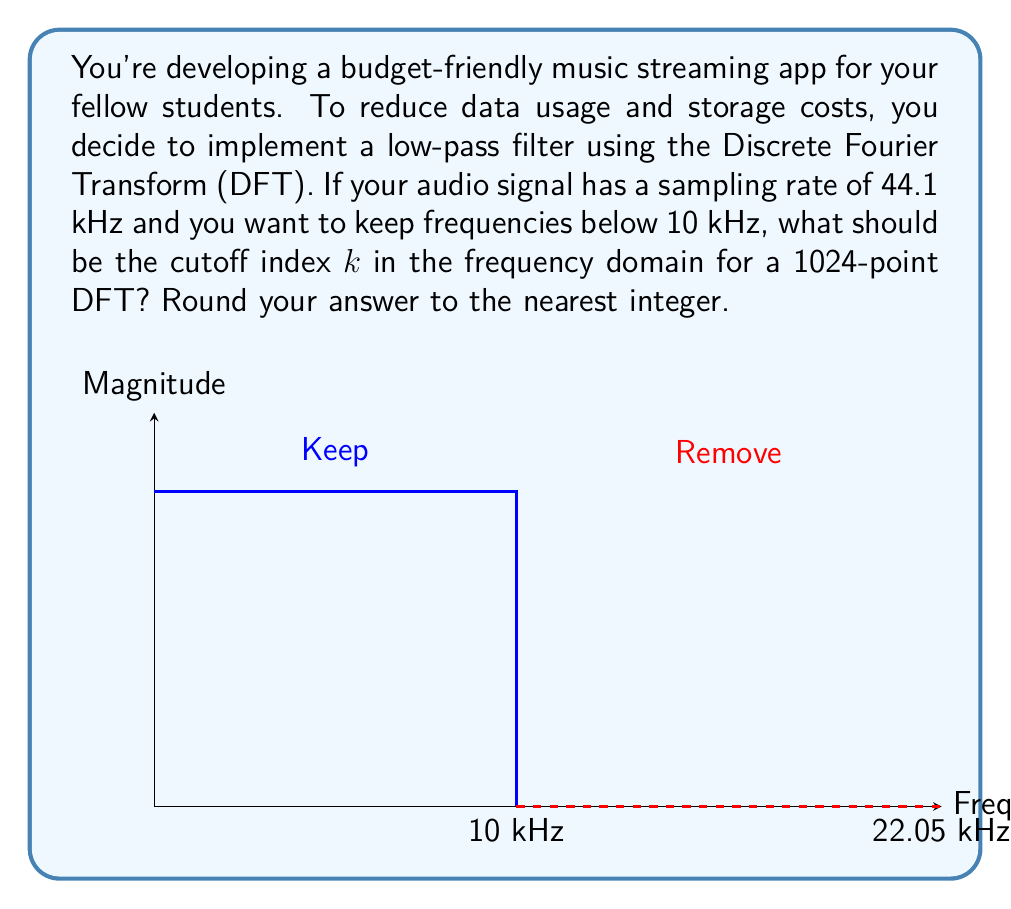Provide a solution to this math problem. Let's approach this step-by-step:

1) In a DFT, the frequency resolution is given by:
   $$\Delta f = \frac{f_s}{N}$$
   where $f_s$ is the sampling rate and $N$ is the number of points in the DFT.

2) Given:
   $f_s = 44.1$ kHz
   $N = 1024$

3) Calculate the frequency resolution:
   $$\Delta f = \frac{44.1 \text{ kHz}}{1024} \approx 43.07 \text{ Hz}$$

4) The cutoff frequency is 10 kHz. We need to find how many $\Delta f$ intervals this corresponds to:
   $$k = \frac{10 \text{ kHz}}{\Delta f} = \frac{10000 \text{ Hz}}{43.07 \text{ Hz}} \approx 232.18$$

5) Rounding to the nearest integer:
   $k \approx 232$

6) Note: In a 1024-point DFT, indices 0 to 511 represent frequencies from 0 to 22.05 kHz (half the sampling rate). Index 232 corresponds to approximately 10 kHz.
Answer: 232 